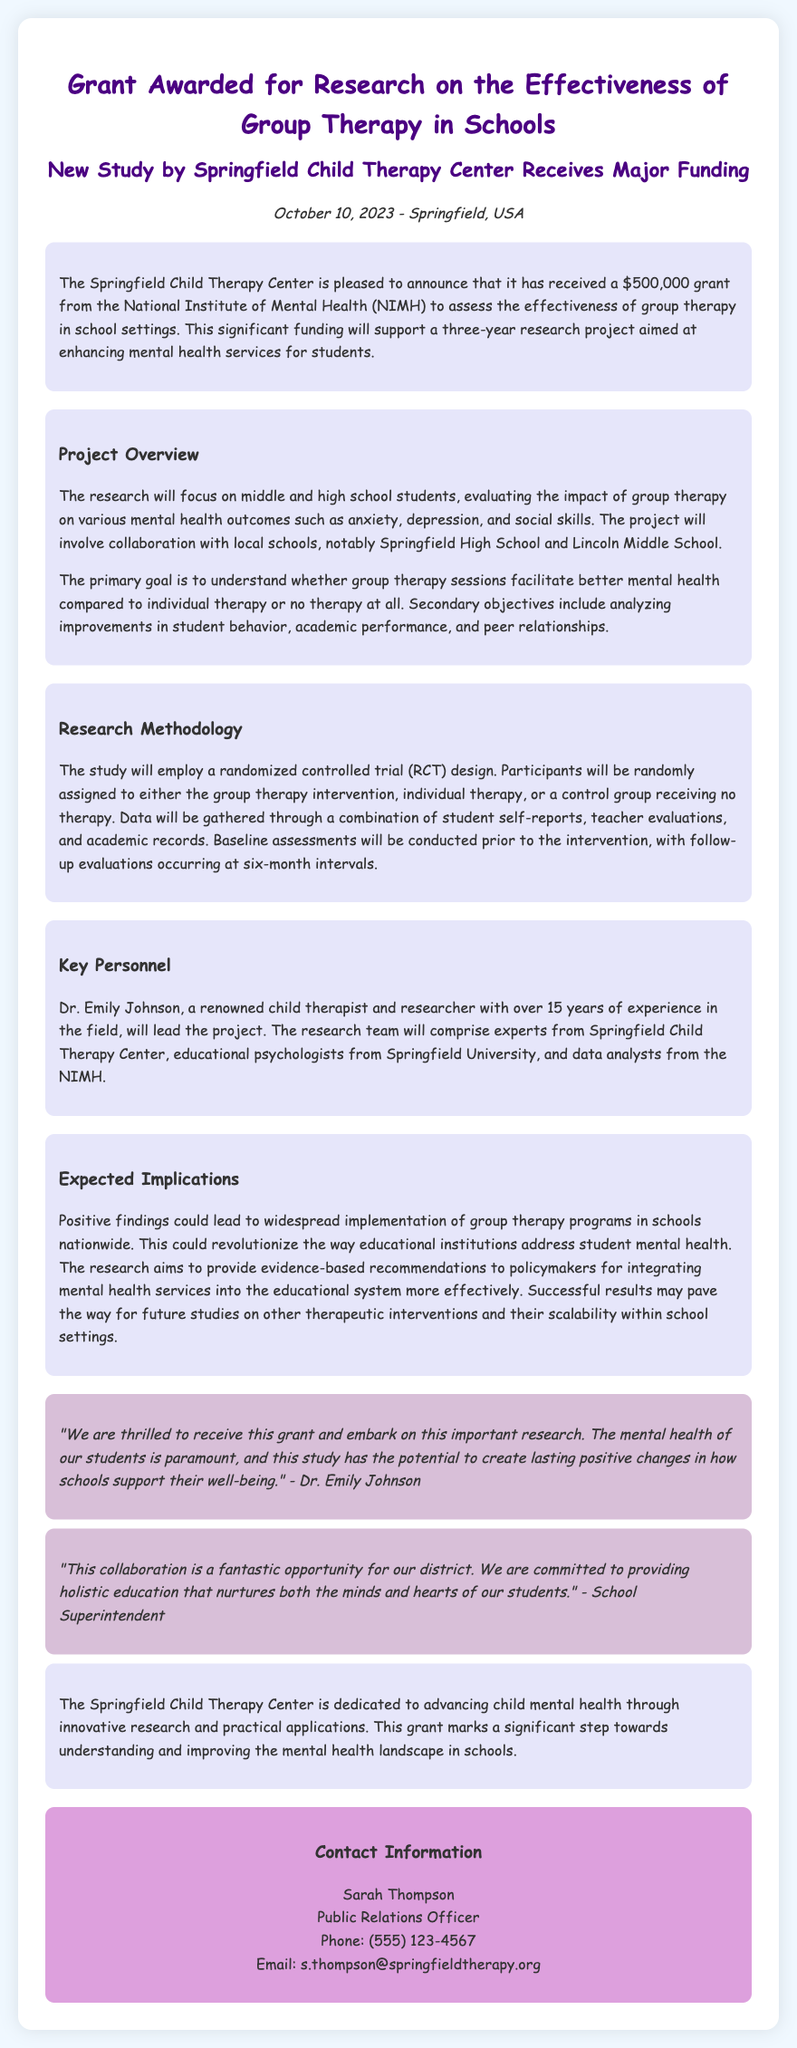What is the amount of the grant awarded? The grant awarded to the Springfield Child Therapy Center is specified in the document as $500,000.
Answer: $500,000 Who will lead the project? The document states that Dr. Emily Johnson will lead the project, highlighting her role as a renowned child therapist and researcher.
Answer: Dr. Emily Johnson What schools are involved in the project? According to the document, the research will collaborate with Springfield High School and Lincoln Middle School.
Answer: Springfield High School and Lincoln Middle School What is the primary goal of the research? The primary goal as mentioned in the document is to understand whether group therapy sessions facilitate better mental health compared to other types of therapy.
Answer: Understand whether group therapy sessions facilitate better mental health What is the research methodology used in the study? The document describes the research methodology as a randomized controlled trial (RCT) design.
Answer: Randomized controlled trial (RCT) design What is the expected implication of positive findings? The document suggests that positive findings could lead to the widespread implementation of group therapy programs in schools nationwide, transforming mental health support in education.
Answer: Widespread implementation of group therapy programs in schools When was the grant announced? The announcement date given in the document is October 10, 2023.
Answer: October 10, 2023 What type of evaluations will be conducted? The document mentions that data will be gathered through student self-reports, teacher evaluations, and academic records.
Answer: Student self-reports, teacher evaluations, and academic records 